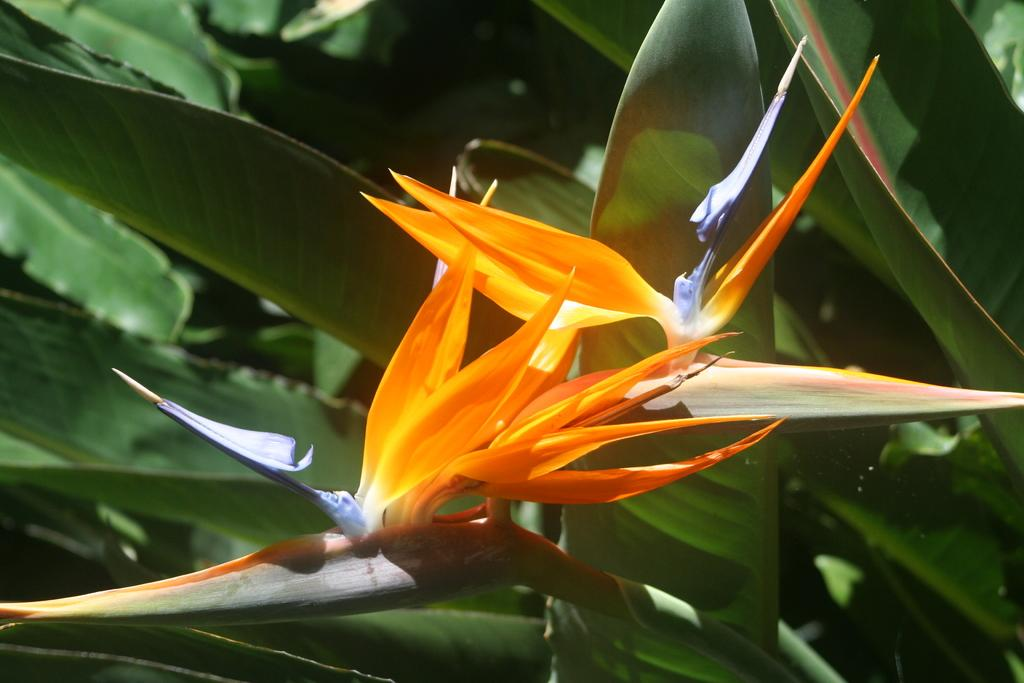What is the main subject in the front of the image? There is a flower in the front of the image. What can be seen in the background of the image? There are leaves in the background of the image. Where is the shelf located in the image? There is no shelf present in the image. What type of crook can be seen in the image? There is no crook present in the image. 